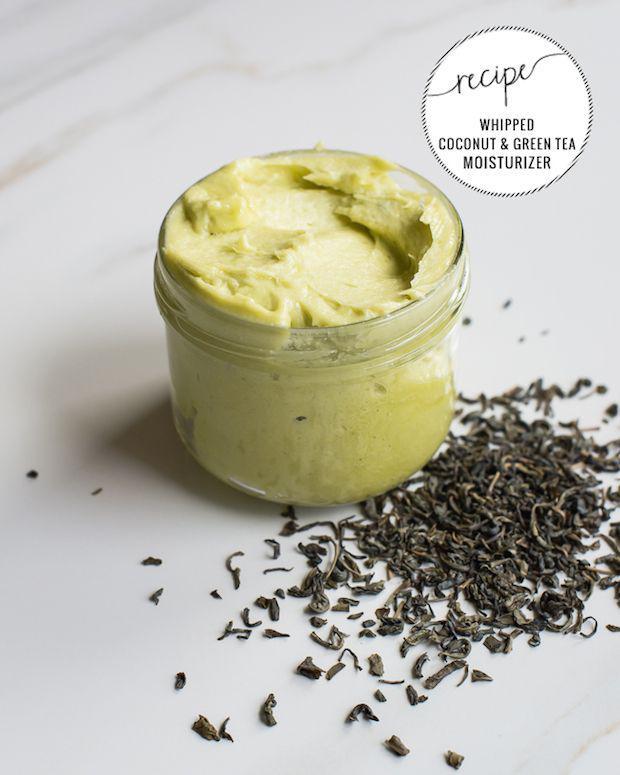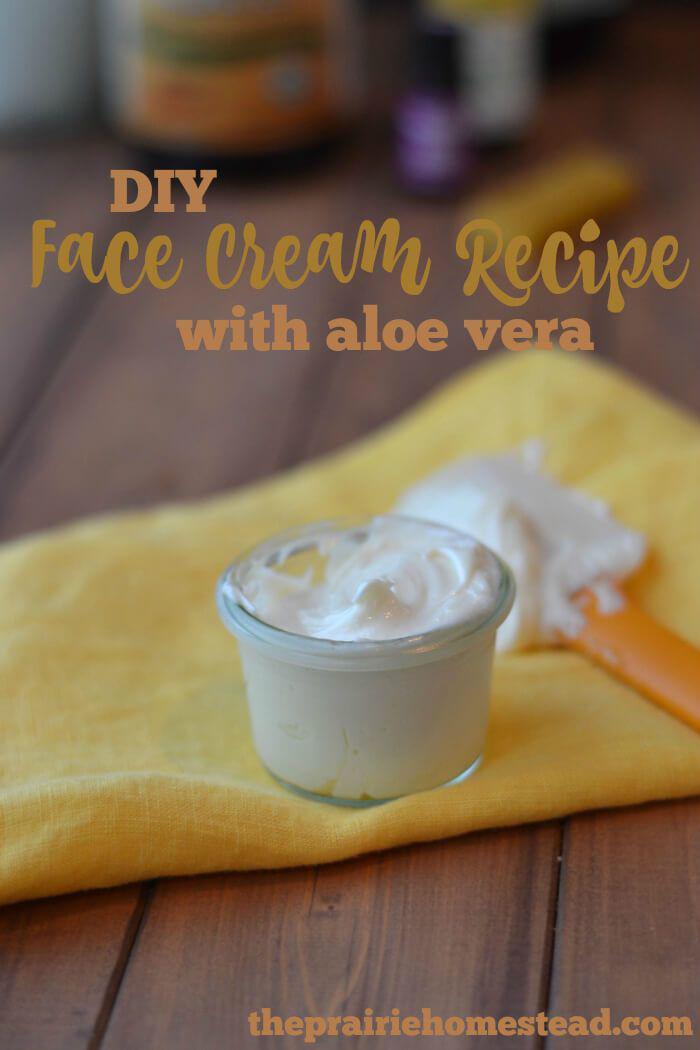The first image is the image on the left, the second image is the image on the right. For the images displayed, is the sentence "None of the creams are green." factually correct? Answer yes or no. No. The first image is the image on the left, the second image is the image on the right. Assess this claim about the two images: "There are no spoons or spatulas in any of the images.". Correct or not? Answer yes or no. No. 